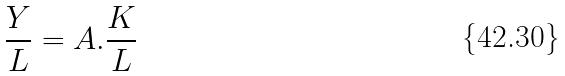Convert formula to latex. <formula><loc_0><loc_0><loc_500><loc_500>\frac { Y } { L } = A . \frac { K } { L }</formula> 